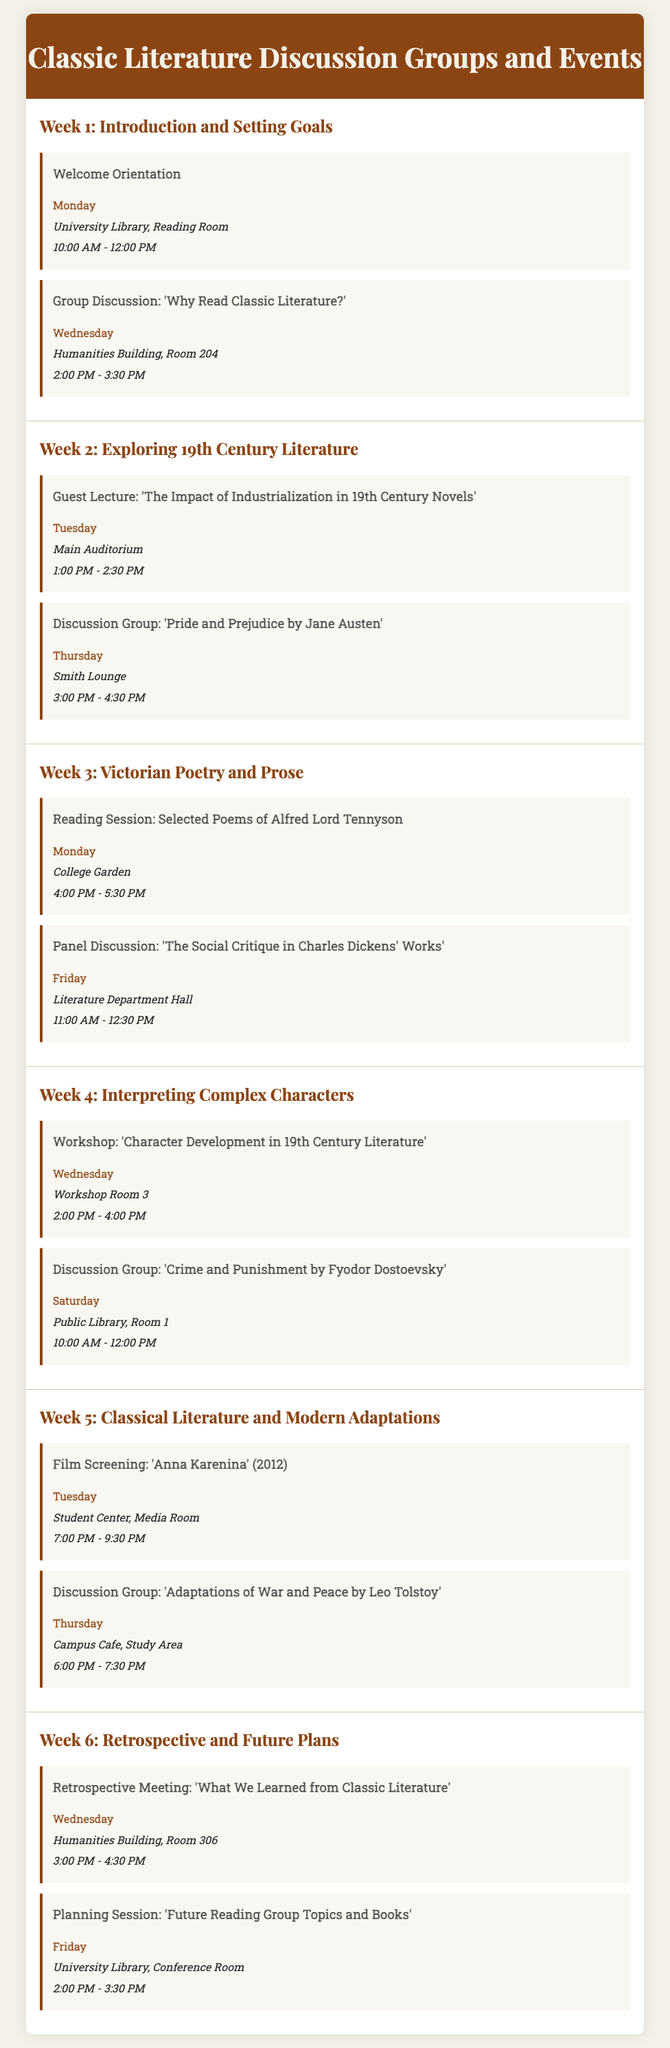What is the title of the program? The title of the program is displayed prominently at the top of the document.
Answer: Classic Literature Discussion Groups and Events What is the day and time of the 'Welcome Orientation'? The document specifies the day and time for the 'Welcome Orientation,' which includes both details together.
Answer: Monday, 10:00 AM - 12:00 PM Which author is discussed in the Week 2 discussion group? The discussion group in Week 2 focuses on a specific book, which is listed in the activities.
Answer: Jane Austen What is the location of the film screening of 'Anna Karenina'? The document states the location for the film screening activity, which can be found under Week 5.
Answer: Student Center, Media Room What workshop is scheduled for Week 4? The document provides details about a specific workshop scheduled in Week 4, indicating the focus of the activity.
Answer: Character Development in 19th Century Literature How many weeks are covered in the itinerary? The number of weeks can be counted based on the sections present in the document, indicating how many weeks are planned for the program.
Answer: Six What activity occurs on Friday of Week 6? The specific activity scheduled for Friday of Week 6 is detailed in the document for that week.
Answer: Planning Session: 'Future Reading Group Topics and Books' In which week does the guest lecture take place? The guest lecture is mentioned in relation to a specific week, allowing for the retrieval of that particular information.
Answer: Week 2 